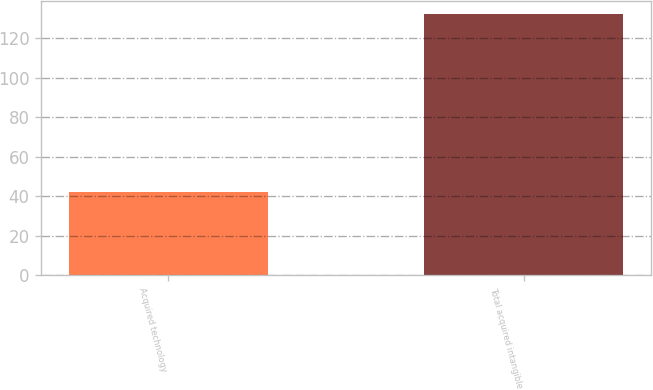Convert chart. <chart><loc_0><loc_0><loc_500><loc_500><bar_chart><fcel>Acquired technology<fcel>Total acquired intangible<nl><fcel>42<fcel>132<nl></chart> 